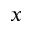Convert formula to latex. <formula><loc_0><loc_0><loc_500><loc_500>x</formula> 